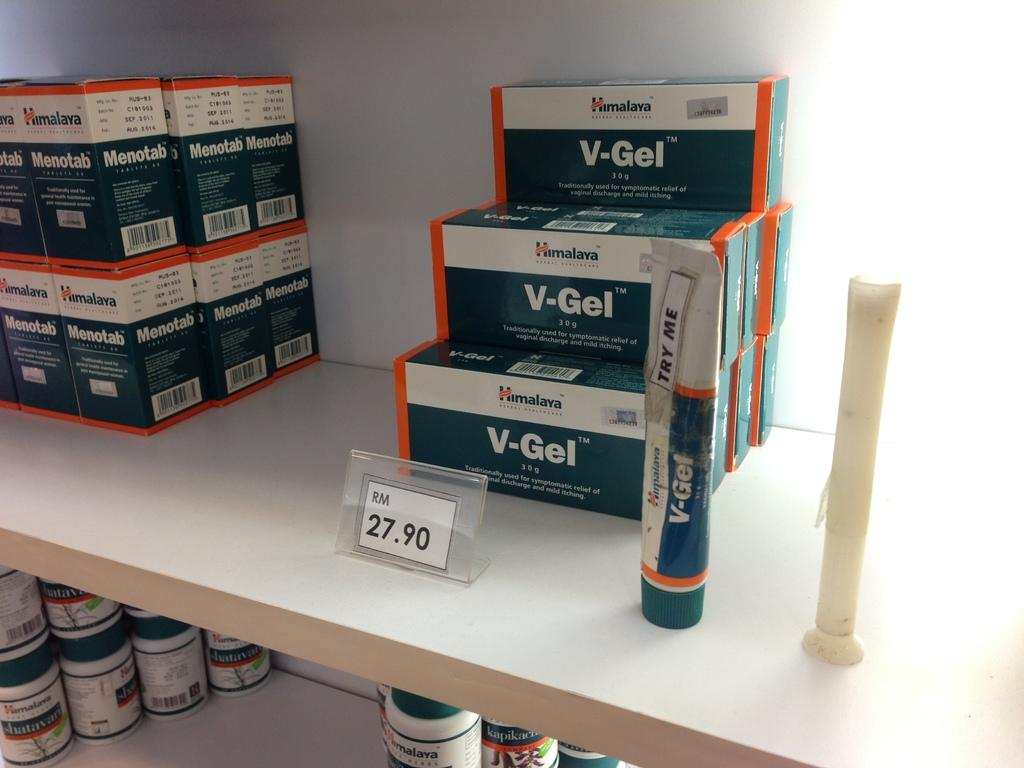What types of containers are visible in the image? There are bottles and boxes in the image. Where are these containers located? They are on a shelf in the image. What other objects might be present on the shelf? There are other objects on the shelf in the image, but their specific nature is not mentioned in the facts. What type of carpenter is shown working on a voyage in the image? There is no carpenter or voyage present in the image; it only features bottles, boxes, and other objects on a shelf. 